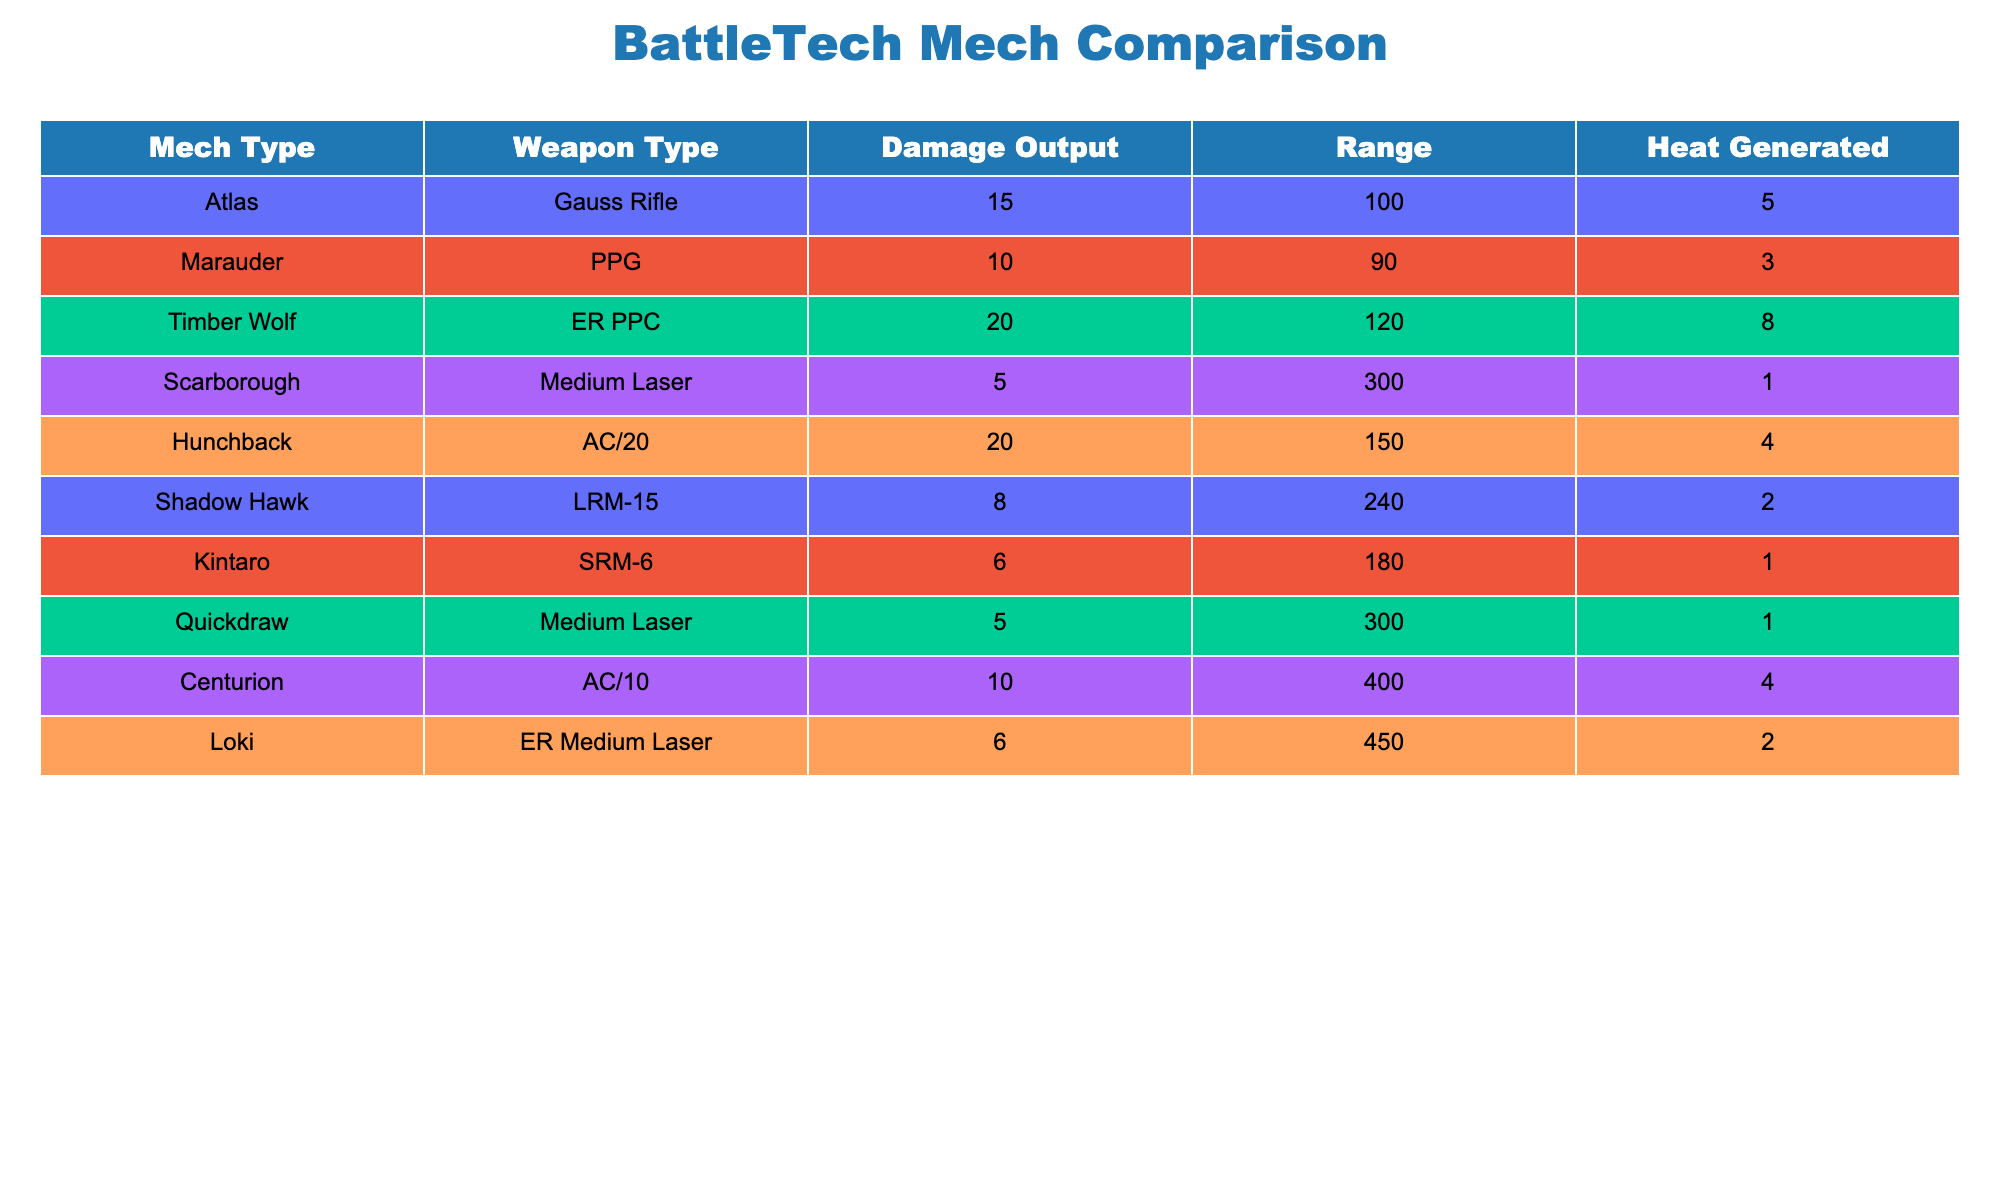What is the damage output of the Atlas mech using the Gauss Rifle? The table displays each mech type along with their respective weapon, damage output, range, and heat generated. For the Atlas mech, the weapon listed is the Gauss Rifle which has a damage output of 15.
Answer: 15 Which mech type has the highest damage output and what is that value? By scanning the damage output column, the Timber Wolf with the ER PPC weapon yields the highest damage output at 20.
Answer: 20 How much damage output does the Hunchback's AC/20 produce? The table indicates that the Hunchback mech with the AC/20 weapon has a damage output of 20.
Answer: 20 Is the range of the Marauder's weapon greater than 100? The range of the Marauder's PPG is listed as 90, which is not greater than 100, hence the answer is no.
Answer: No What is the total damage output of both the Atlas and Hunchback mechs combined? The Atlas has a damage output of 15 and the Hunchback has a damage output of 20. Adding these values gives 15 + 20 = 35. Therefore, the total damage output is 35.
Answer: 35 Which mech produces the least heat and what is the value? The columns show that the Kintaro with the SRM-6 and both Quickdraw and Scarborough with their Medium Lasers all produce only 1 heat, which is the least compared to other mechs.
Answer: 1 What is the average damage output of all the mechs listed in the table? Adding all the damage outputs: 15 + 10 + 20 + 5 + 20 + 8 + 6 + 5 + 10 + 6 = 105. There are 10 mechs total; the average is 105 / 10 = 10.5.
Answer: 10.5 Is the Shadow Hawk more heat efficient than the Atlas? The Shadow Hawk with the LRM-15 produces 2 heat for 8 damage, while the Atlas with the Gauss Rifle produces 5 heat for 15 damage. Comparing the heat per damage, the Shadow Hawk has a ratio of 0.25 and the Atlas's is 0.33. Thus, Shadow Hawk is more heat efficient.
Answer: Yes What is the difference in damage output between the highest and lowest damage weapons? The highest damage output is 20 (Timber Wolf and Hunchback), and the lowest is 5 (Quickdraw and Scarborough). The difference is 20 - 5 = 15.
Answer: 15 